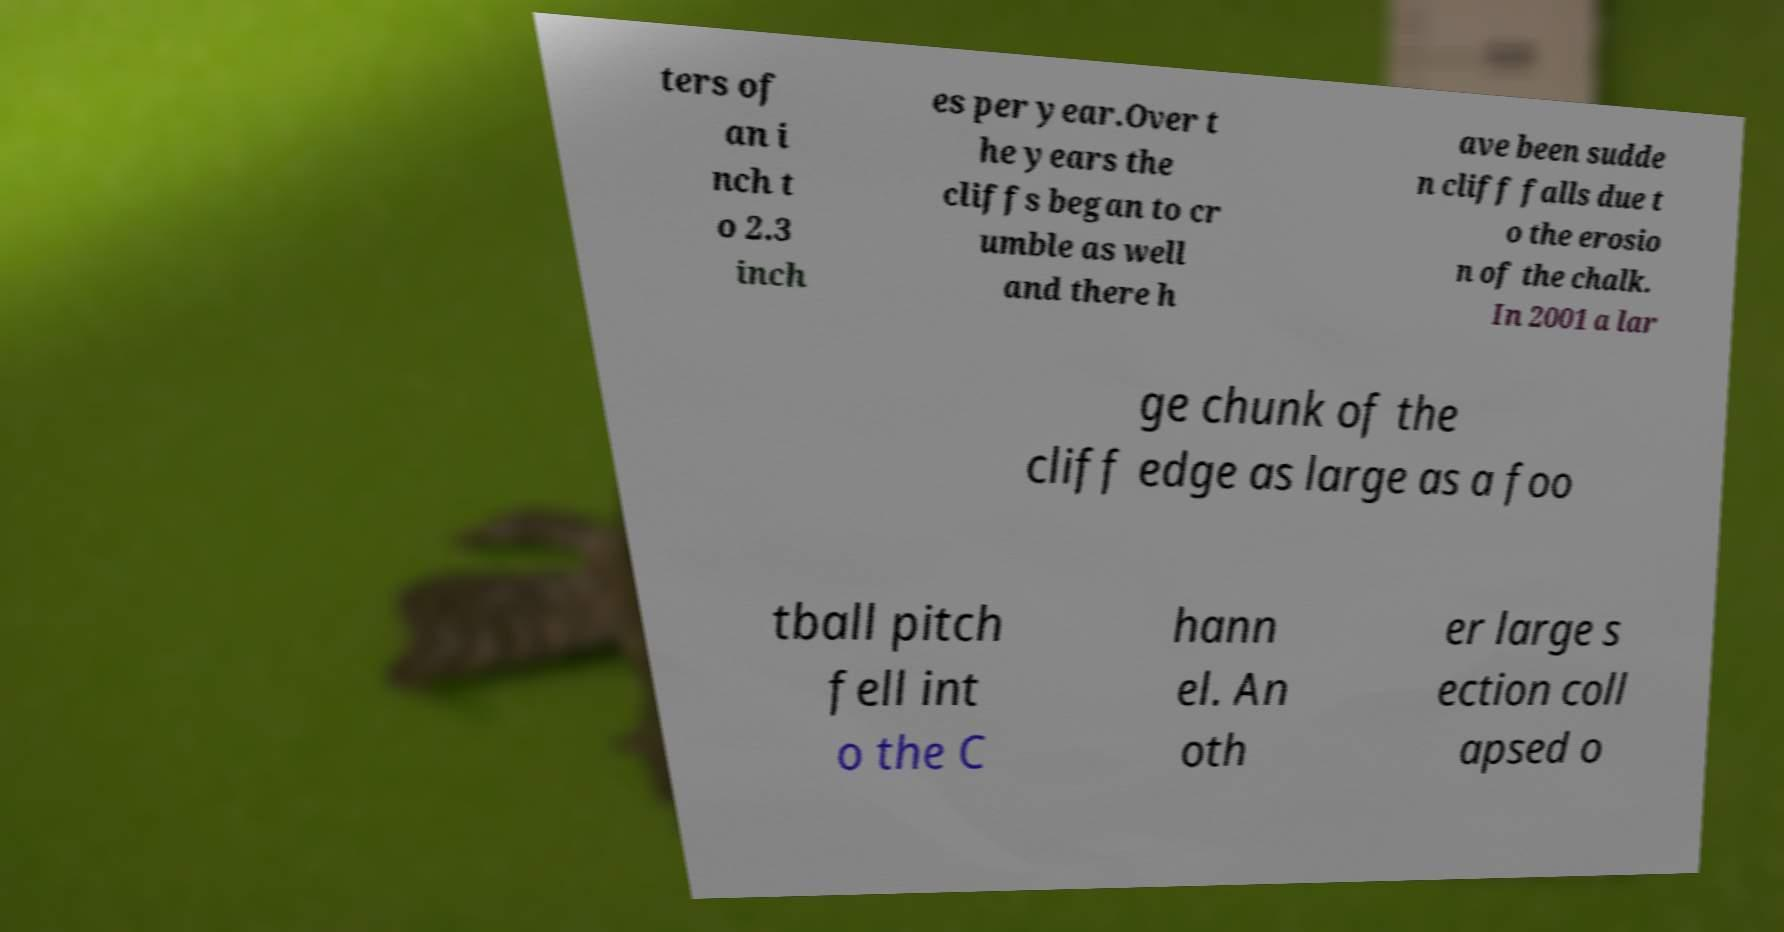Please read and relay the text visible in this image. What does it say? ters of an i nch t o 2.3 inch es per year.Over t he years the cliffs began to cr umble as well and there h ave been sudde n cliff falls due t o the erosio n of the chalk. In 2001 a lar ge chunk of the cliff edge as large as a foo tball pitch fell int o the C hann el. An oth er large s ection coll apsed o 